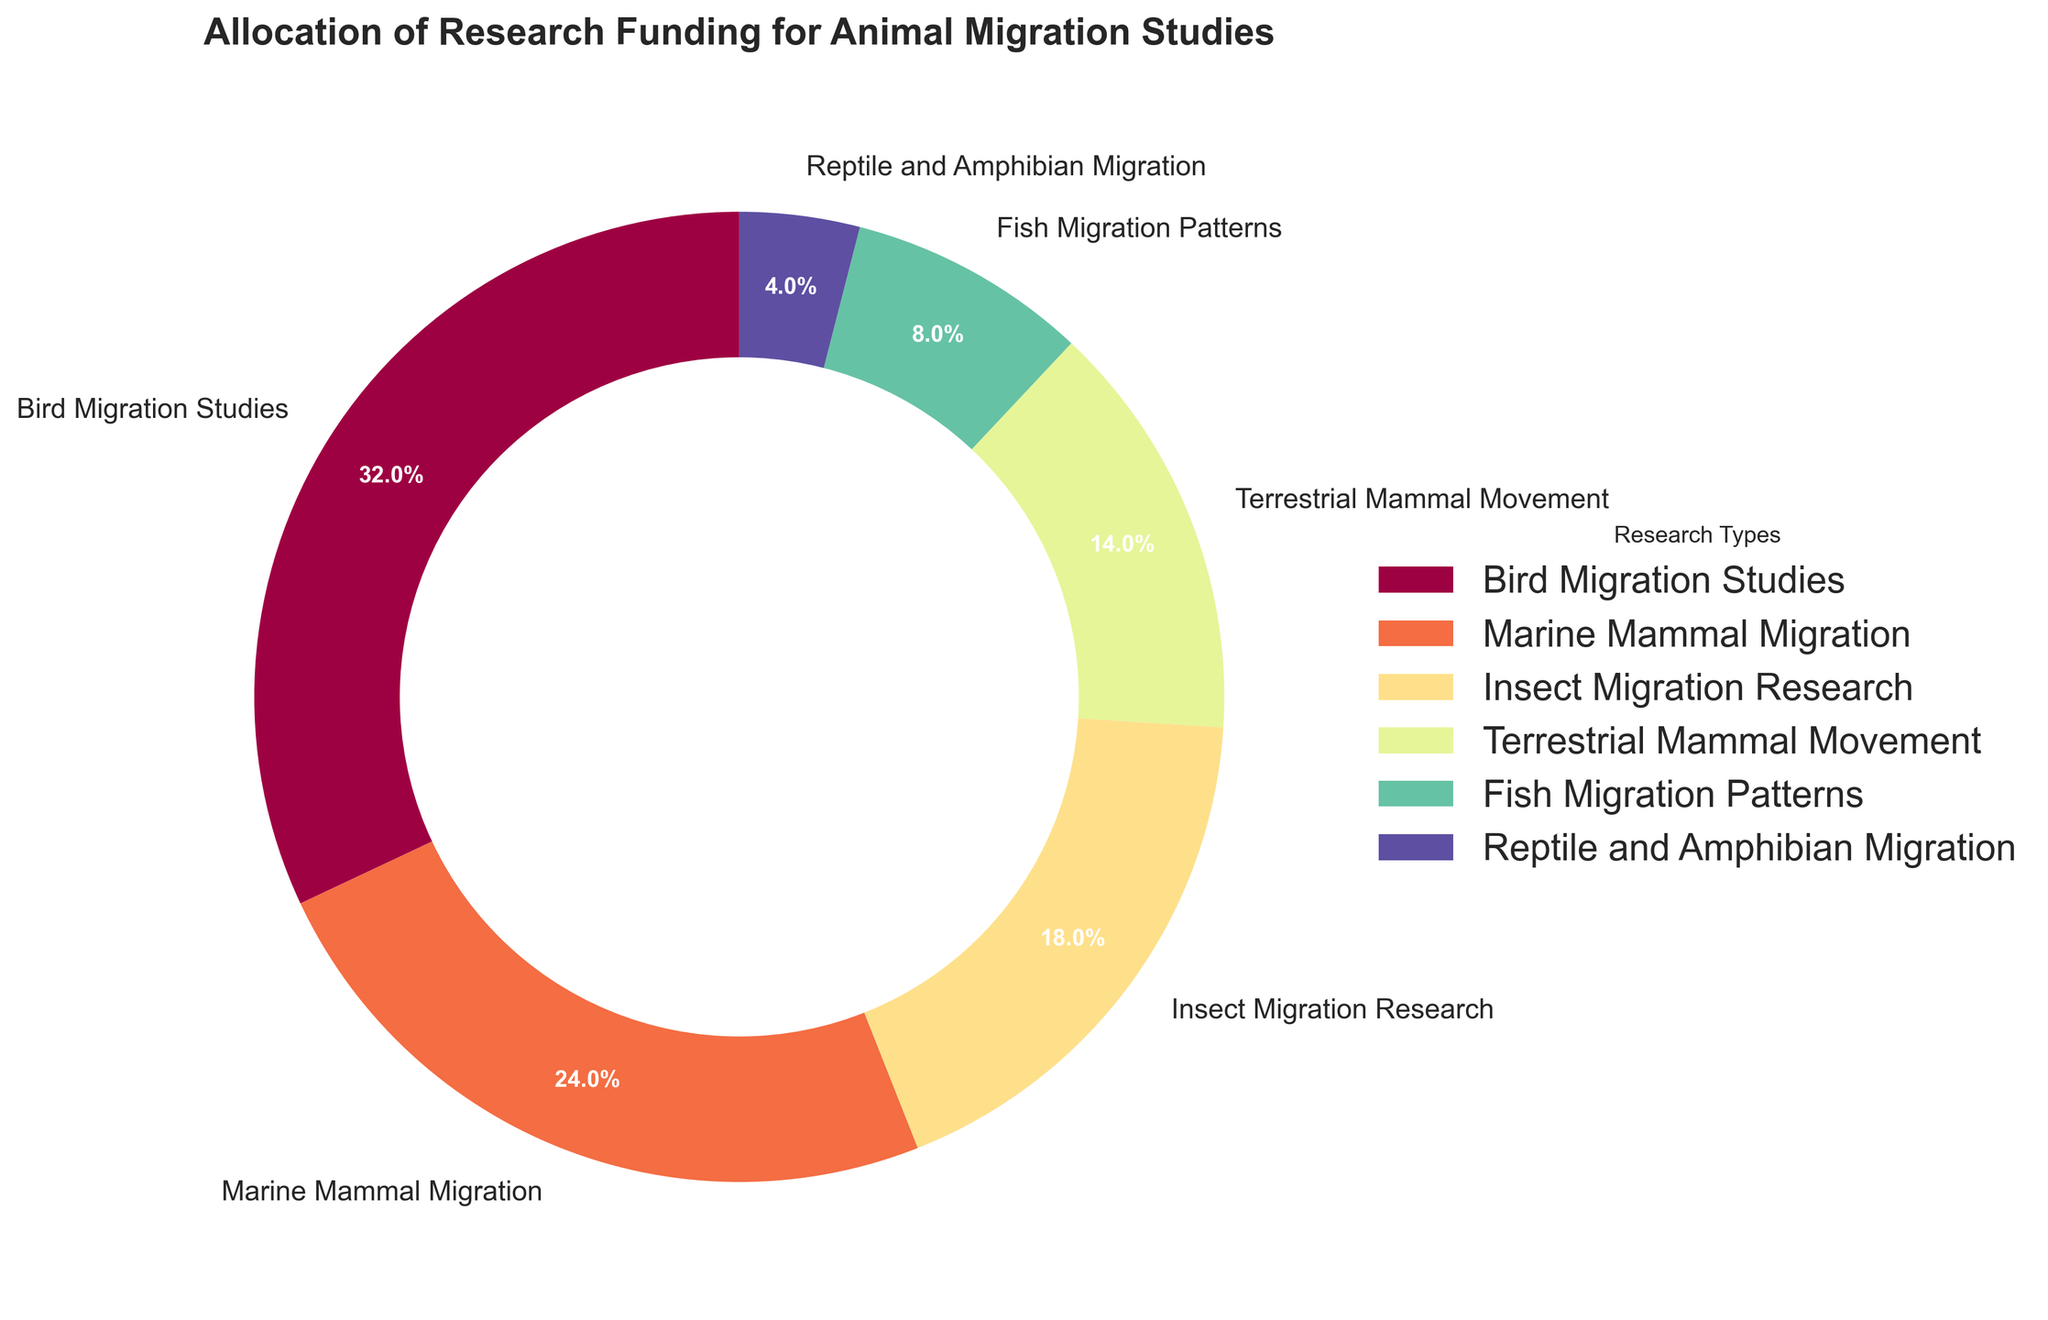What percentage of the funding is allocated to Marine Mammal Migration studies? The pie chart shows that Marine Mammal Migration received 24% of the total research funding.
Answer: 24% Which research type received the least amount of funding? By examining the pie chart, we can see that Reptile and Amphibian Migration studies received the smallest slice, indicating the least funding at 4%.
Answer: Reptile and Amphibian Migration How much more funding does Bird Migration Studies receive compared to Fish Migration Patterns? Bird Migration Studies received 32% while Fish Migration Patterns received 8%. Subtract the smaller percentage from the larger one: 32% - 8% = 24%.
Answer: 24% Combine the funding percentages for Terrestrial Mammal Movement and Insect Migration Research. What is the total percentage? Terrestrial Mammal Movement received 14% and Insect Migration Research received 18%. Adding these two gives us 14% + 18% = 32%.
Answer: 32% Is the funding for Terrestrial Mammal Movement greater than, less than, or equal to Fish Migration Patterns plus Reptile and Amphibian Migration? Terrestrial Mammal Movement received 14%. Fish Migration Patterns and Reptile and Amphibian Migration received 8% and 4% respectively. Adding Fish and Reptile/Amphibian funding: 8% + 4% = 12%. 14% is greater than 12%.
Answer: Greater than What is the most funded research type? The pie chart indicates that Bird Migration Studies have the largest slice, marking the highest funding at 32%.
Answer: Bird Migration Studies How much combined funding do Marine Mammal Migration and Bird Migration Studies receive? Marine Mammal Migration received 24% and Bird Migration Studies received 32%. Adding these together gives us 24% + 32% = 56%.
Answer: 56% What is the funding difference between Insect Migration Research and Terrestrial Mammal Movement? Insect Migration Research received 18% and Terrestrial Mammal Movement received 14%. The difference is 18% - 14% = 4%.
Answer: 4% Which research types receive more funding than Fish Migration Patterns? The pie chart shows that Bird Migration Studies (32%), Marine Mammal Migration (24%), Insect Migration Research (18%), and Terrestrial Mammal Movement (14%) all receive more funding than Fish Migration Patterns (8%).
Answer: Bird Migration Studies, Marine Mammal Migration, Insect Migration Research, Terrestrial Mammal Movement What color is used to represent Bird Migration Studies? The pie chart uses distinguishable colors, where the color of the largest slice, representing Bird Migration Studies (32%), can be identified visually.
Answer: [Note: Specify the actual color based on the visual appearance of the chart, typically indicated by the most dominant color in the chart's legend.] 